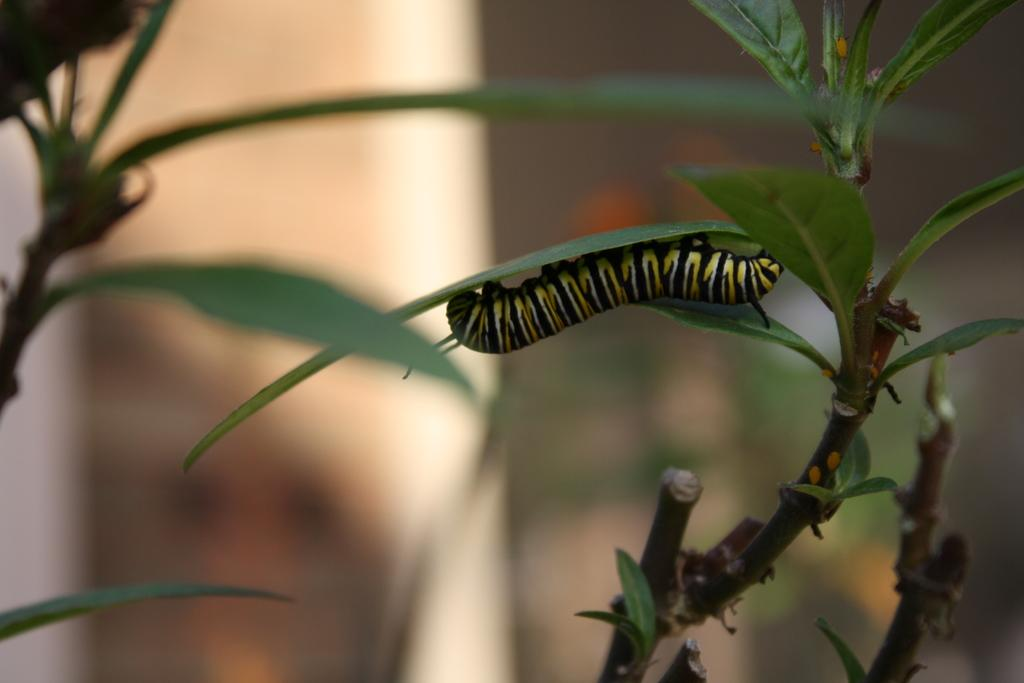What is on the leaf in the image? There is an insect on a leaf in the image. What else can be seen in the image besides the insect? There are plants in the image. Can you describe the background of the image? The background of the image is blurry. What type of lettuce is being used as a jail for the insect in the image? There is no lettuce or jail present in the image; it features an insect on a leaf with plants in the background. 